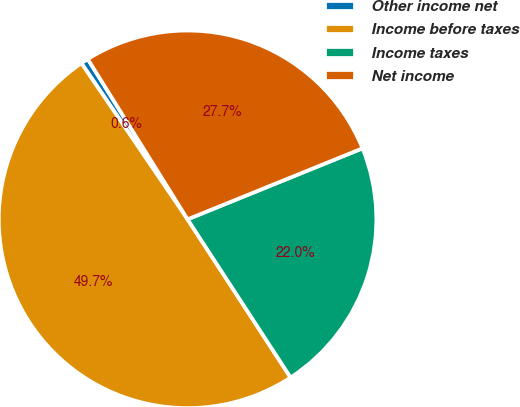Convert chart. <chart><loc_0><loc_0><loc_500><loc_500><pie_chart><fcel>Other income net<fcel>Income before taxes<fcel>Income taxes<fcel>Net income<nl><fcel>0.64%<fcel>49.68%<fcel>21.95%<fcel>27.73%<nl></chart> 